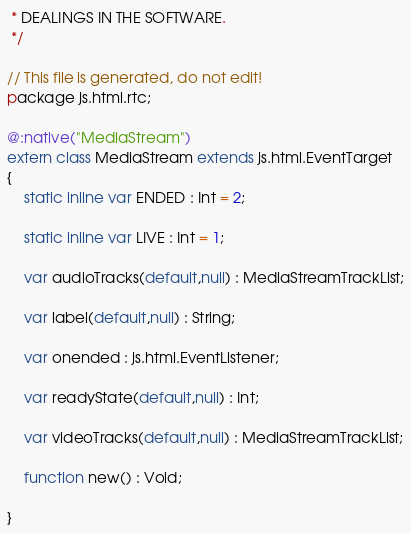Convert code to text. <code><loc_0><loc_0><loc_500><loc_500><_Haxe_> * DEALINGS IN THE SOFTWARE.
 */

// This file is generated, do not edit!
package js.html.rtc;

@:native("MediaStream")
extern class MediaStream extends js.html.EventTarget
{
	static inline var ENDED : Int = 2;

	static inline var LIVE : Int = 1;

	var audioTracks(default,null) : MediaStreamTrackList;

	var label(default,null) : String;

	var onended : js.html.EventListener;

	var readyState(default,null) : Int;

	var videoTracks(default,null) : MediaStreamTrackList;

	function new() : Void;

}
</code> 